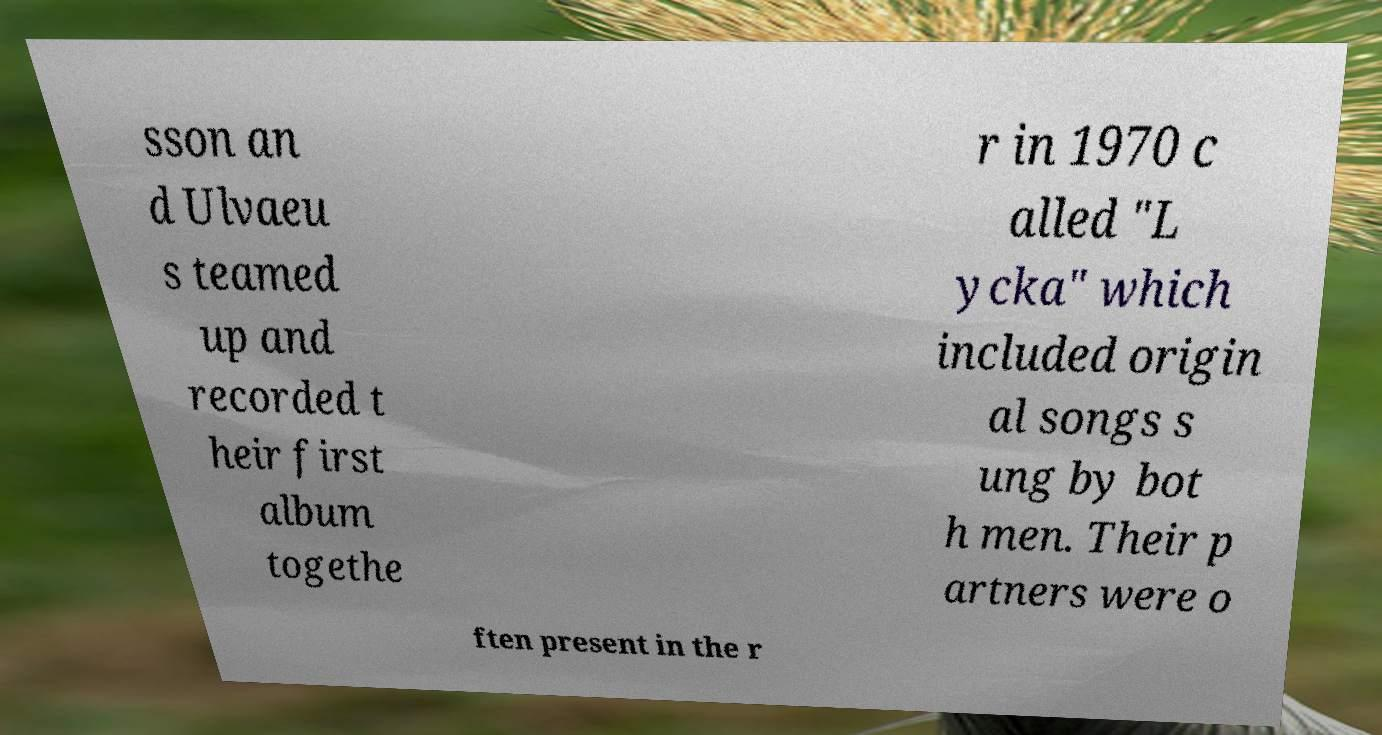For documentation purposes, I need the text within this image transcribed. Could you provide that? sson an d Ulvaeu s teamed up and recorded t heir first album togethe r in 1970 c alled "L ycka" which included origin al songs s ung by bot h men. Their p artners were o ften present in the r 